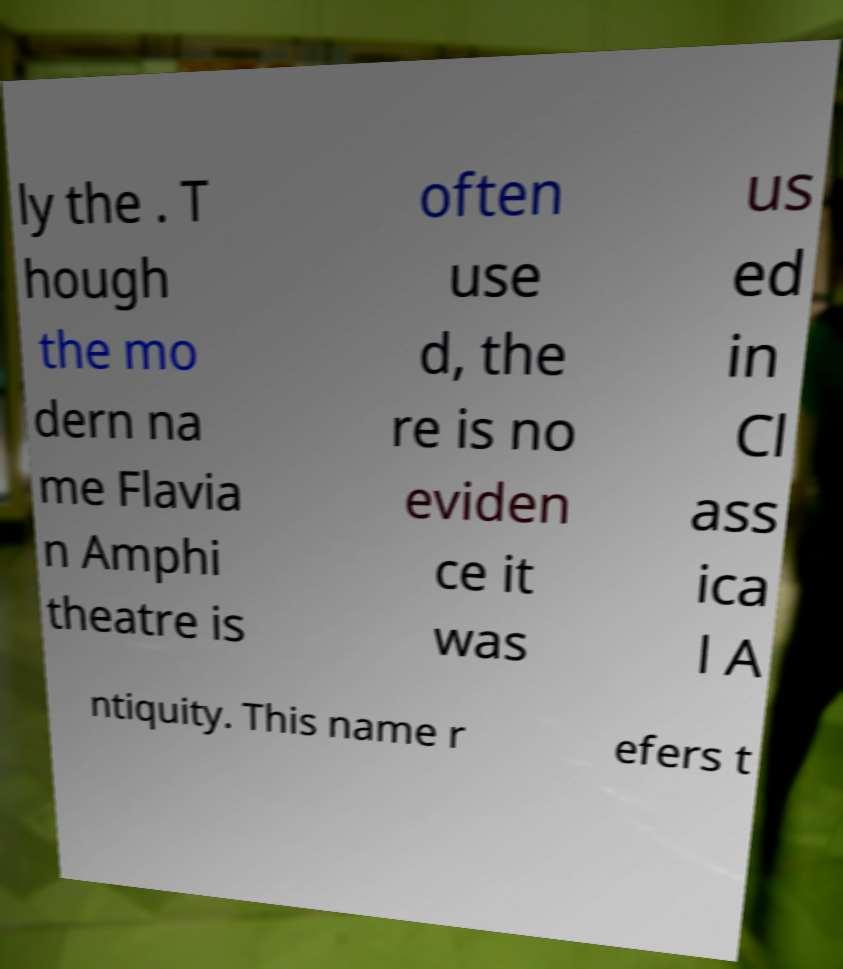I need the written content from this picture converted into text. Can you do that? ly the . T hough the mo dern na me Flavia n Amphi theatre is often use d, the re is no eviden ce it was us ed in Cl ass ica l A ntiquity. This name r efers t 